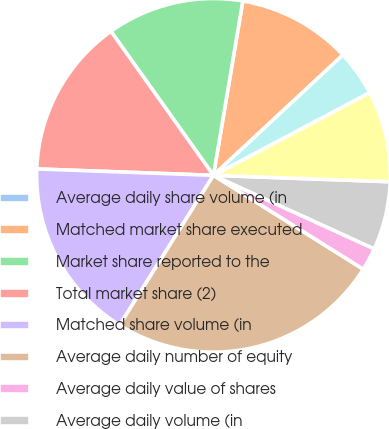Convert chart. <chart><loc_0><loc_0><loc_500><loc_500><pie_chart><fcel>Average daily share volume (in<fcel>Matched market share executed<fcel>Market share reported to the<fcel>Total market share (2)<fcel>Matched share volume (in<fcel>Average daily number of equity<fcel>Average daily value of shares<fcel>Average daily volume (in<fcel>NASDAQ OMX PHLX matched market<fcel>The NASDAQ Options Market<nl><fcel>0.0%<fcel>10.42%<fcel>12.5%<fcel>14.58%<fcel>16.67%<fcel>25.0%<fcel>2.08%<fcel>6.25%<fcel>8.33%<fcel>4.17%<nl></chart> 